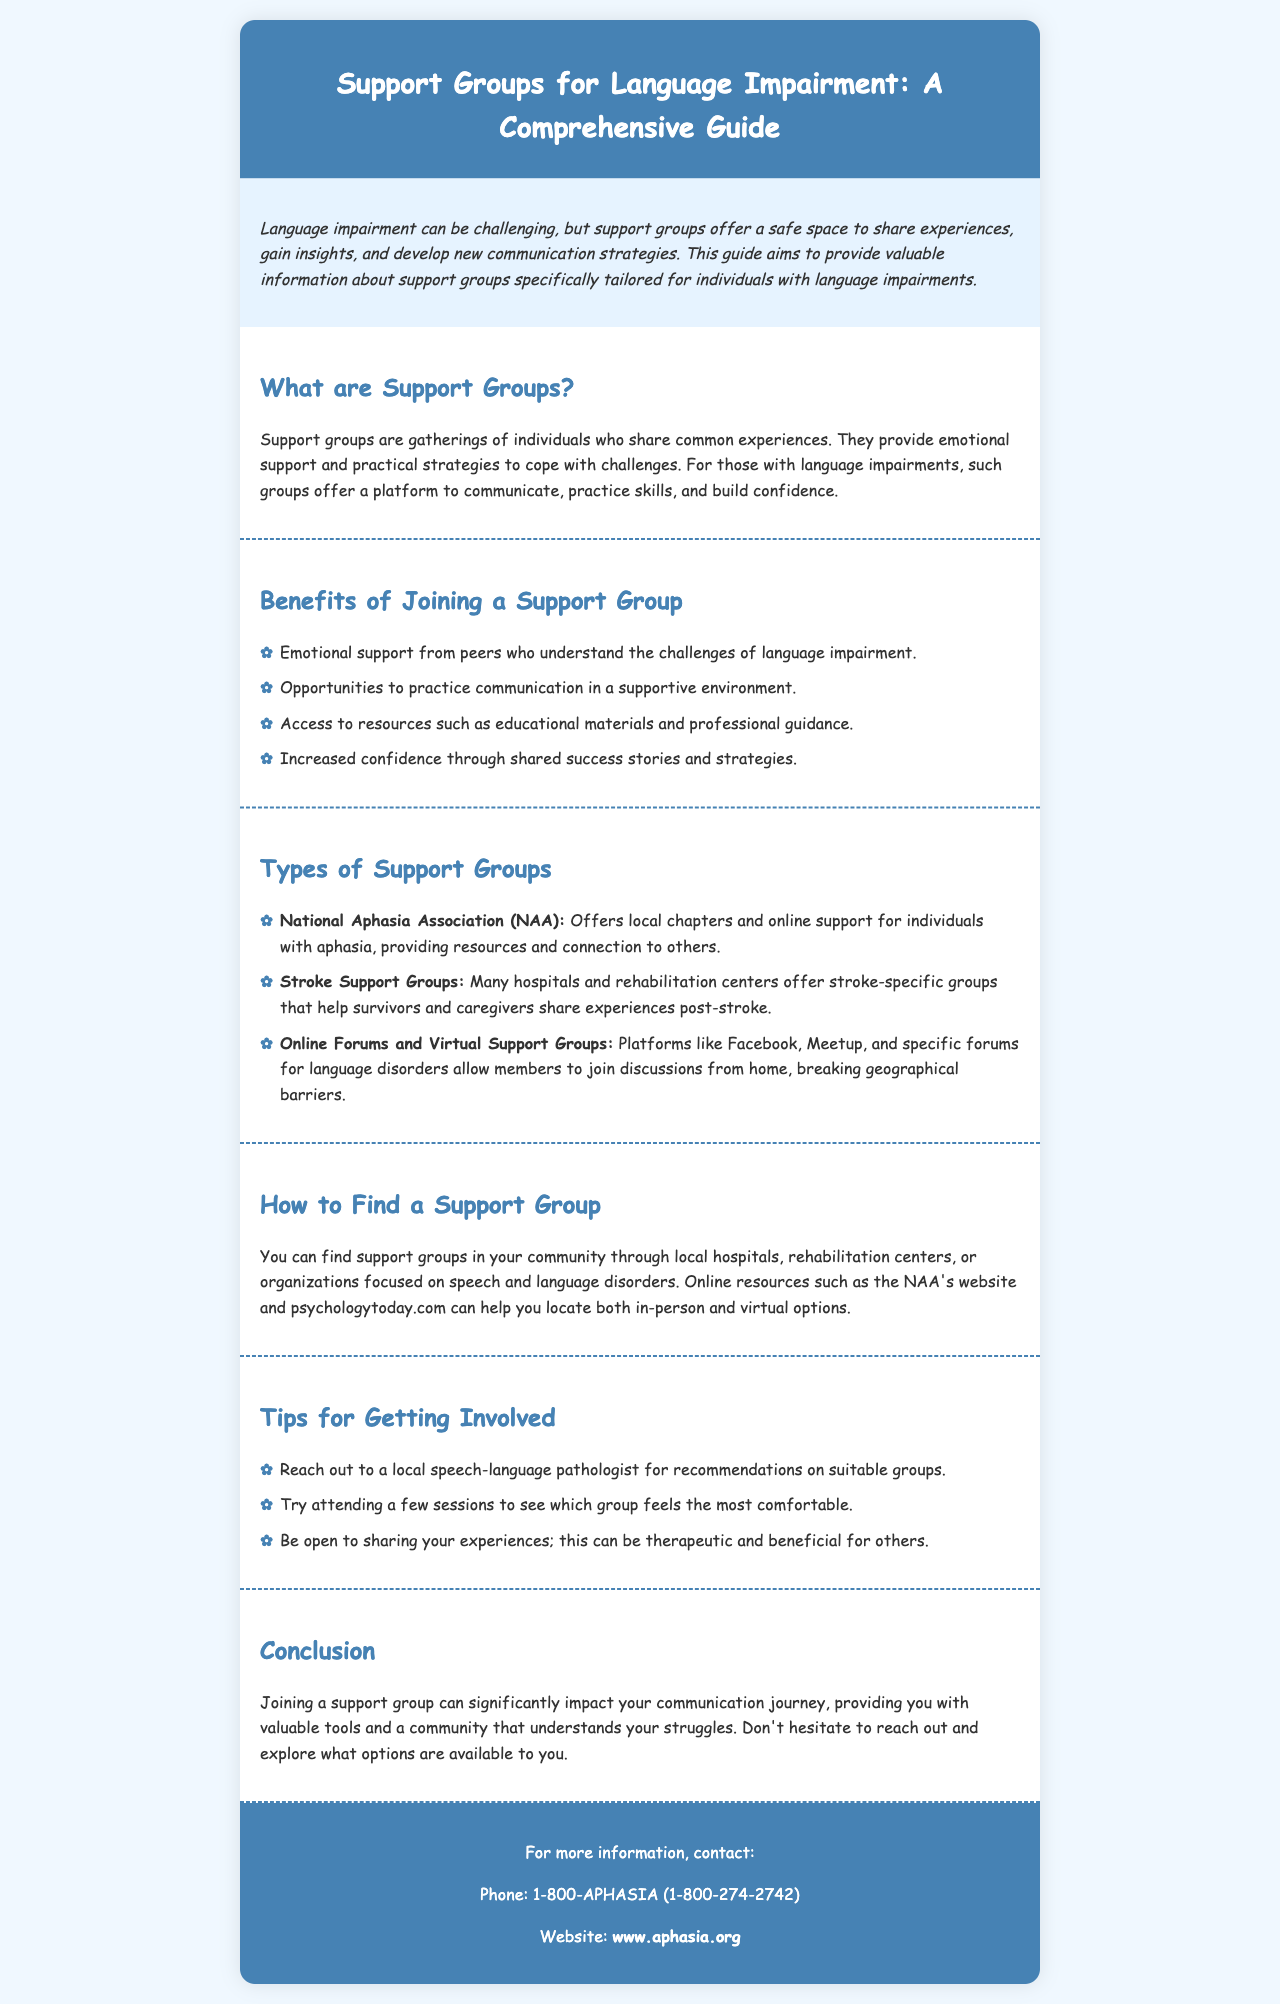What is the purpose of support groups? Support groups provide emotional support and practical strategies to cope with challenges related to language impairment.
Answer: Emotional support and practical strategies What organization offers local chapters for individuals with aphasia? The document mentions the National Aphasia Association provides local chapters and online support.
Answer: National Aphasia Association How many benefits of joining a support group are listed? The document lists four specific benefits of joining a support group.
Answer: Four What type of support group is specifically mentioned for stroke survivors? Stroke-specific groups offered by hospitals and rehabilitation centers are mentioned.
Answer: Stroke Support Groups What is one tip for getting involved in a support group? The document suggests reaching out to a local speech-language pathologist for recommendations.
Answer: Reach out to a local speech-language pathologist Where can you find support groups in your community? You can find support groups through local hospitals, rehabilitation centers, or organizations focused on speech and language disorders.
Answer: Local hospitals, rehabilitation centers, or organizations What is the phone number provided for more information? The phone number listed for contact is 1-800-APHASIA or 1-800-274-2742.
Answer: 1-800-APHASIA (1-800-274-2742) What is a recommended platform for online discussions? The document mentions Facebook as a platform for online discussions regarding language disorders.
Answer: Facebook 